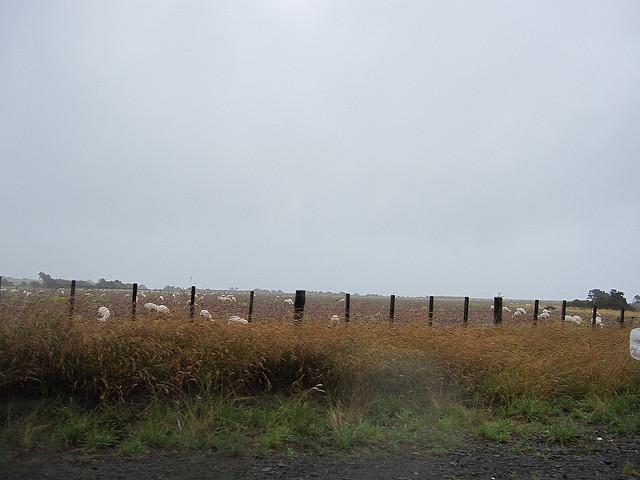How many fence posts can you count?
Give a very brief answer. 14. How many sheep can you see?
Give a very brief answer. 1. How many books are there?
Give a very brief answer. 0. 